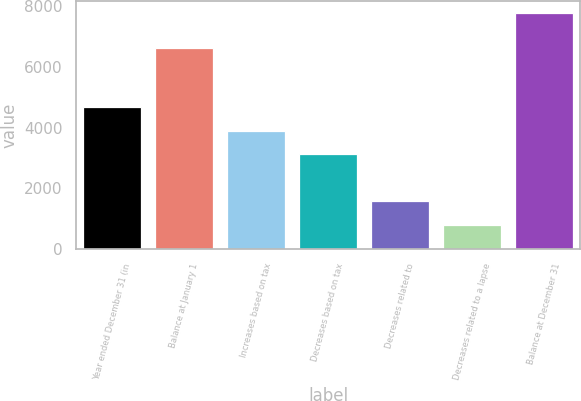<chart> <loc_0><loc_0><loc_500><loc_500><bar_chart><fcel>Year ended December 31 (in<fcel>Balance at January 1<fcel>Increases based on tax<fcel>Decreases based on tax<fcel>Decreases related to<fcel>Decreases related to a lapse<fcel>Balance at December 31<nl><fcel>4669.8<fcel>6608<fcel>3895.5<fcel>3121.2<fcel>1572.6<fcel>798.3<fcel>7767<nl></chart> 